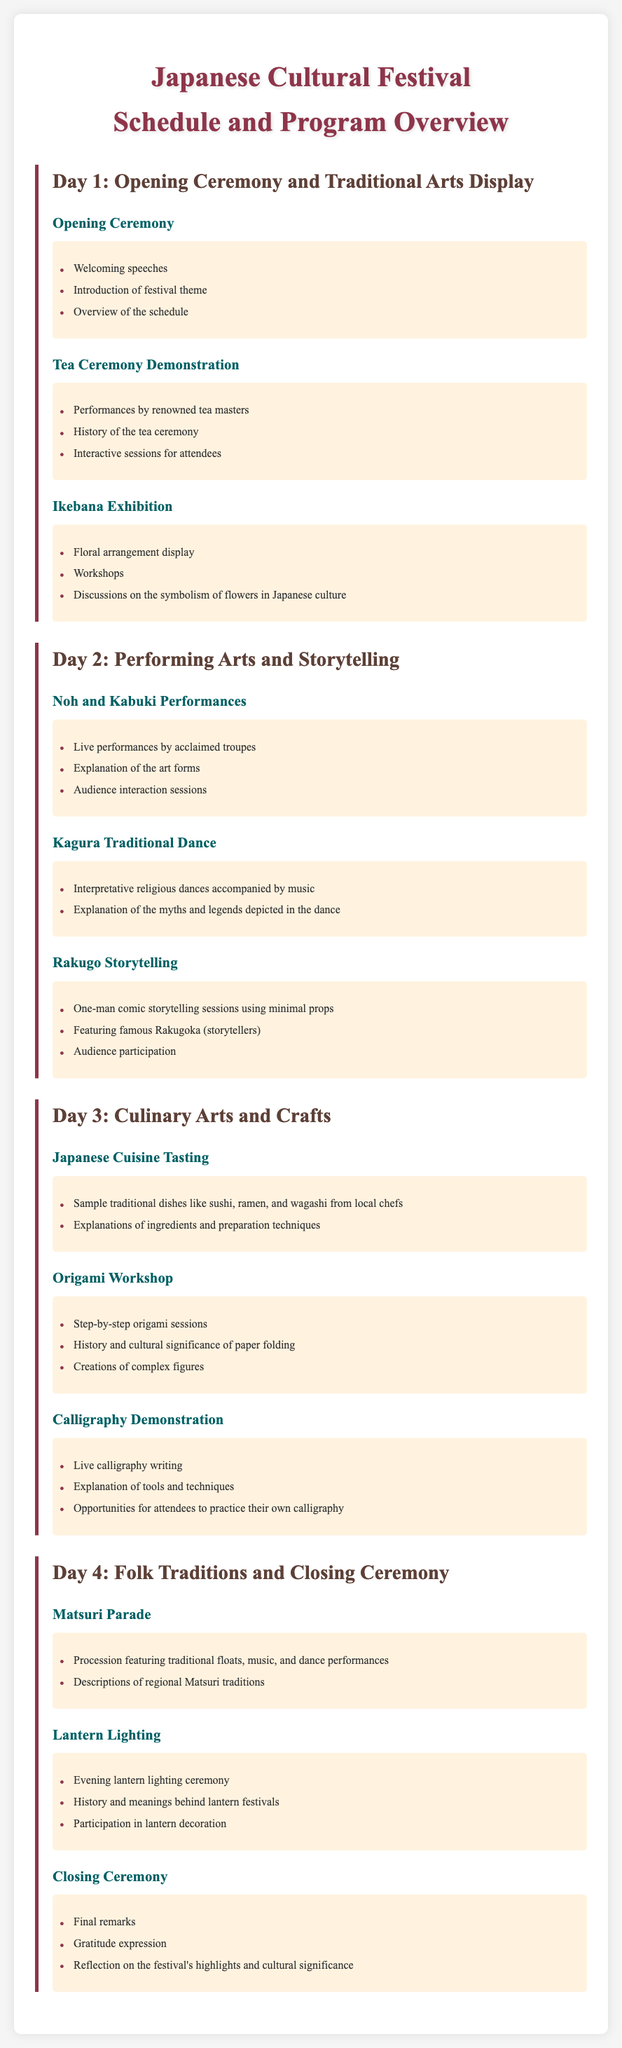What is the title of the festival? The title is found in the heading of the document, which states the event name and purpose.
Answer: Japanese Cultural Festival - Schedule and Program Overview How many days is the festival scheduled for? The document outlines a breakdown of events for four distinct days.
Answer: 4 What is featured on Day 2 of the festival? Referring to the section that describes activities for Day 2, it includes performances and storytelling.
Answer: Performing Arts and Storytelling Who gives the welcoming speeches on Day 1? This is mentioned in the details of the Opening Ceremony indicating the participants of the ceremony.
Answer: Not specified What traditional dance is performed on Day 2? The document explicitly names the traditional dance included in Day 2's program.
Answer: Kagura Traditional Dance Which flower arrangement art form is exhibited on Day 1? The document describes an exhibition related to floral arrangements occurring on Day 1.
Answer: Ikebana Exhibition What type of cuisine is highlighted on Day 3? This information pertains to the culinary activities outlined for Day 3.
Answer: Japanese Cuisine Tasting What activity occurs during the Closing Ceremony on Day 4? The details of the Closing Ceremony indicate this specific activity at the end of the festival.
Answer: Final remarks How are audience members engaged in the Rakugo storytelling? The document details how the audience is involved with the storyteller during the performance.
Answer: Audience participation 